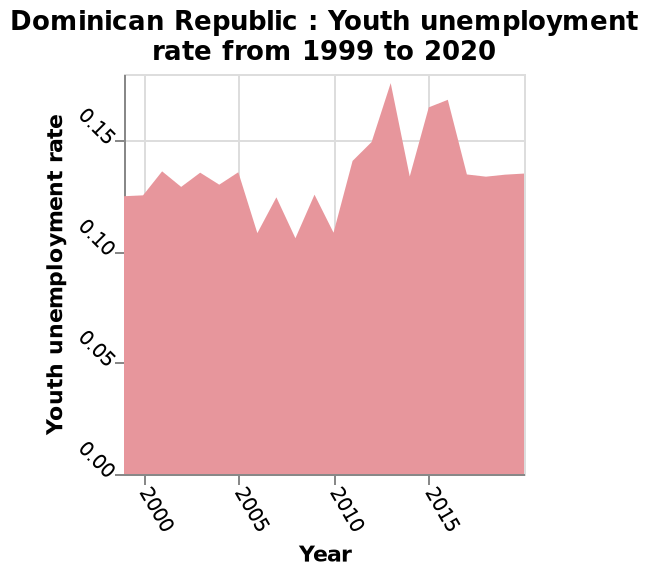<image>
please summary the statistics and relations of the chart Relative up and down unemployment levels that balanced eachother out one after the other to return to an average level of unemployment with unemployment peaking in 2010-2015 followed by a plateau. What happened after the peak of unemployment levels?  After the peak of unemployment levels, there was a plateau. What was the time frame when the relative up and down unemployment levels occurred? The relative up and down unemployment levels occurred one after the other before reaching an average level of unemployment. 